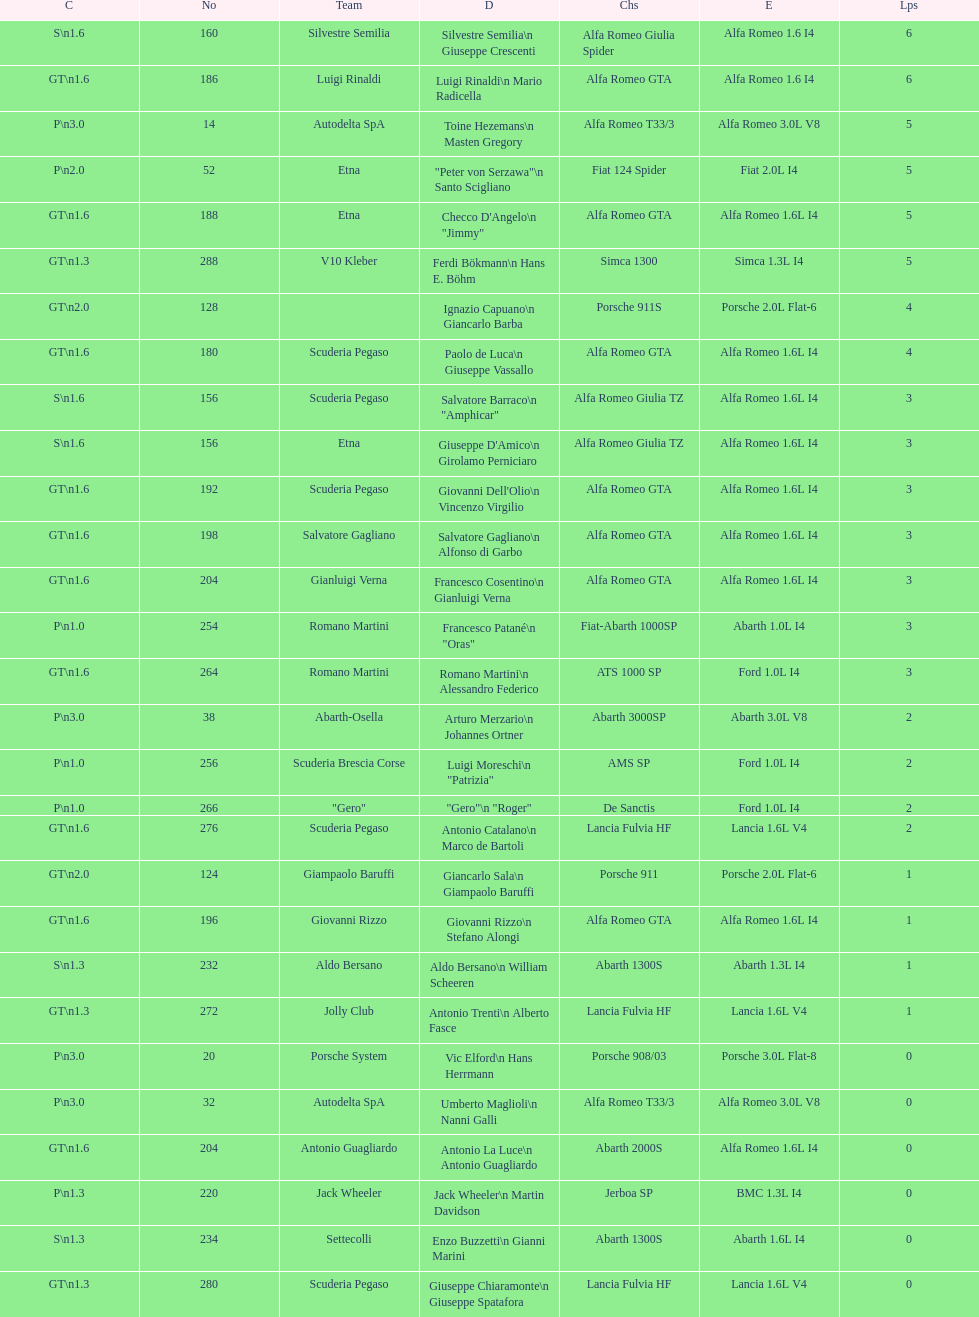How many teams failed to finish the race after 2 laps? 4. 